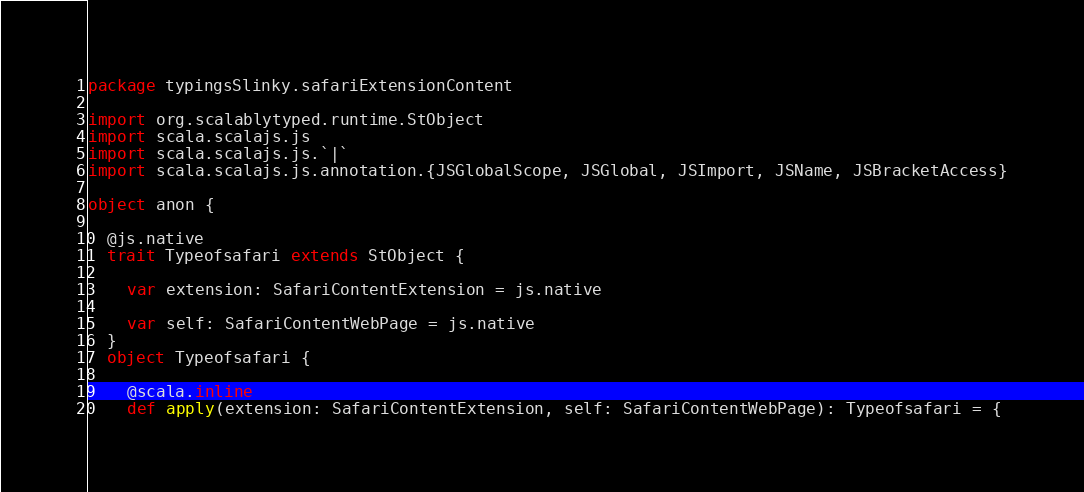<code> <loc_0><loc_0><loc_500><loc_500><_Scala_>package typingsSlinky.safariExtensionContent

import org.scalablytyped.runtime.StObject
import scala.scalajs.js
import scala.scalajs.js.`|`
import scala.scalajs.js.annotation.{JSGlobalScope, JSGlobal, JSImport, JSName, JSBracketAccess}

object anon {
  
  @js.native
  trait Typeofsafari extends StObject {
    
    var extension: SafariContentExtension = js.native
    
    var self: SafariContentWebPage = js.native
  }
  object Typeofsafari {
    
    @scala.inline
    def apply(extension: SafariContentExtension, self: SafariContentWebPage): Typeofsafari = {</code> 